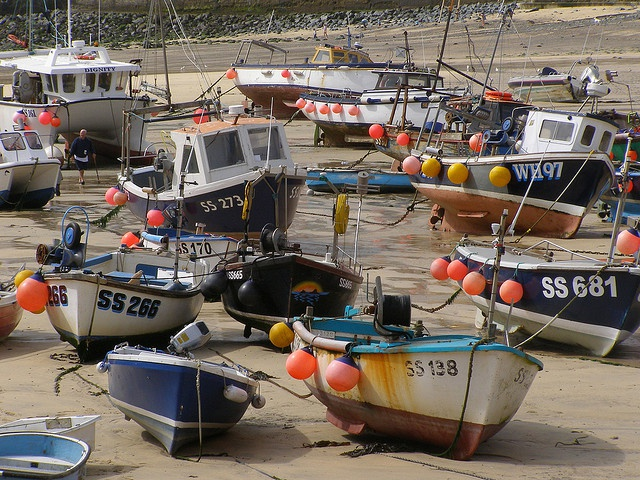Describe the objects in this image and their specific colors. I can see boat in darkgreen, black, gray, darkgray, and maroon tones, boat in darkgreen, black, darkgray, and gray tones, boat in darkgreen, black, gray, darkgray, and olive tones, boat in darkgreen, black, gray, darkgray, and lightgray tones, and boat in darkgreen, black, maroon, gray, and darkgray tones in this image. 